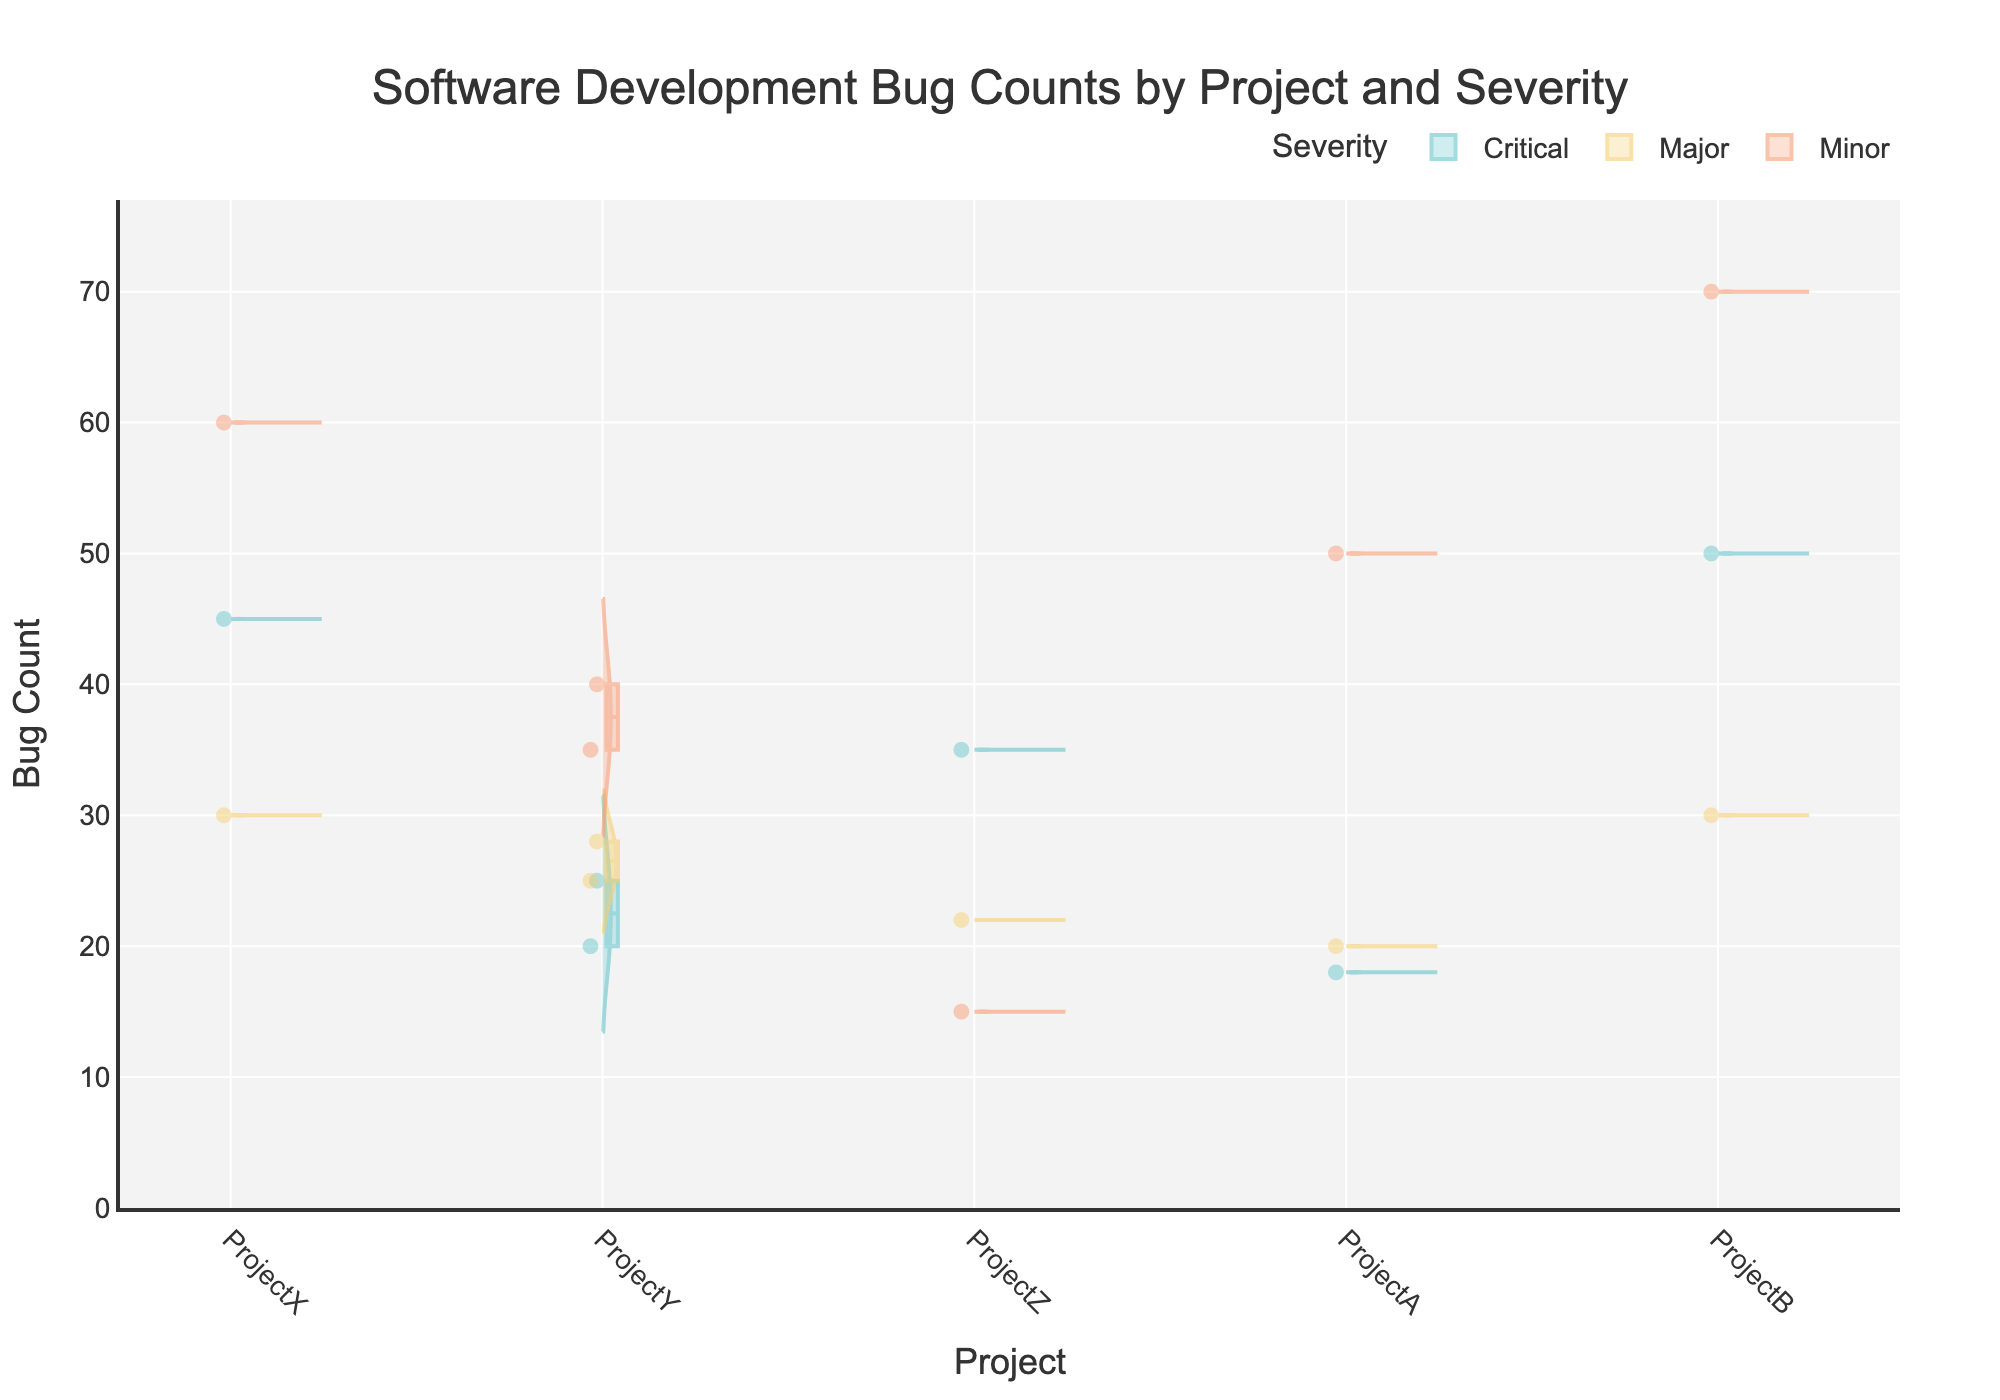How many projects are represented in the figure? The x-axis of the violin chart represents the different projects. By counting the distinct labels on the x-axis, we can identify the number of projects represented.
Answer: 5 What severity level has the highest median bug count in ProjectB? By examining the median lines in the box plots overlaying the violins, we need to compare the Critical, Major, and Minor categories for ProjectB to see which one has the highest median line.
Answer: Minor Which project has the lowest median bug count for Critical severity? Reviewing the median lines (horizontal lines within the box) for Critical severity across all projects, find which project has the lowest median.
Answer: ProjectA What is the median bug count for Major severity in ProjectY? Look at ProjectY's violin plot for Major severity and identify the position of the median line (represented by the horizontal line within the box).
Answer: 25 Compare the range of bug counts for Minor severities between ProjectA and ProjectB. Which one is higher? For both ProjectA and ProjectB, visualize the spread of the Minor severity violins from the bottom to the top. Compare the range indicated by the width of the violins and the height of the box plot whiskers.
Answer: ProjectB Which severity category shows the most variability in bug counts for ProjectX? Observing ProjectX's violins for each severity, the one with the widest and most spread-out violin indicates the most variability. Analyze the spread from bottom to top for each severity.
Answer: Minor Is the median bug count for Critical severity higher in ProjectX or ProjectY? Compare the positions of the median lines in the box plots for Critical severity for both ProjectX and ProjectY. Identify which one is higher.
Answer: ProjectX For Major severity, which project exhibits more outliers in bug counts? Outliers are indicated by individual points outside the boxplot's whiskers in violin plots. Count these points for Major severity across the different projects and identify which project has more.
Answer: ProjectY How does the average bug count for Minor severity across all projects compare to that for Major severity? Calculate the average bug count for Minor and Major severities: sum the bug counts for each category across all projects and divide by the number of data points in each category.
Answer: Minor is higher Are there any projects where the bug count for all severities stayed below 50? Examine the whiskers' maximum values in the box plots for each severity category within every project and check if there's any project where the maximum bug count is less than 50 for all severities.
Answer: ProjectA 